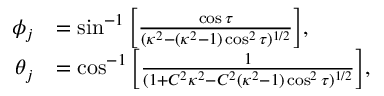Convert formula to latex. <formula><loc_0><loc_0><loc_500><loc_500>\begin{array} { r l } { \phi _ { j } } & { = \sin ^ { - 1 } \left [ \frac { \cos \tau } { ( \kappa ^ { 2 } - ( \kappa ^ { 2 } - 1 ) \cos ^ { 2 } \tau ) ^ { 1 / 2 } } \right ] , } \\ { \theta _ { j } } & { = \cos ^ { - 1 } \left [ \frac { 1 } { ( 1 + C ^ { 2 } \kappa ^ { 2 } - C ^ { 2 } ( \kappa ^ { 2 } - 1 ) \cos ^ { 2 } \tau ) ^ { 1 / 2 } } \right ] , } \end{array}</formula> 